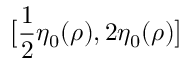<formula> <loc_0><loc_0><loc_500><loc_500>\left [ \frac { 1 } { 2 } \eta _ { 0 } ( \rho ) , 2 \eta _ { 0 } ( \rho ) \right ]</formula> 